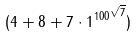Convert formula to latex. <formula><loc_0><loc_0><loc_500><loc_500>( 4 + 8 + 7 \cdot { 1 ^ { 1 0 0 } } ^ { \sqrt { 7 } } )</formula> 